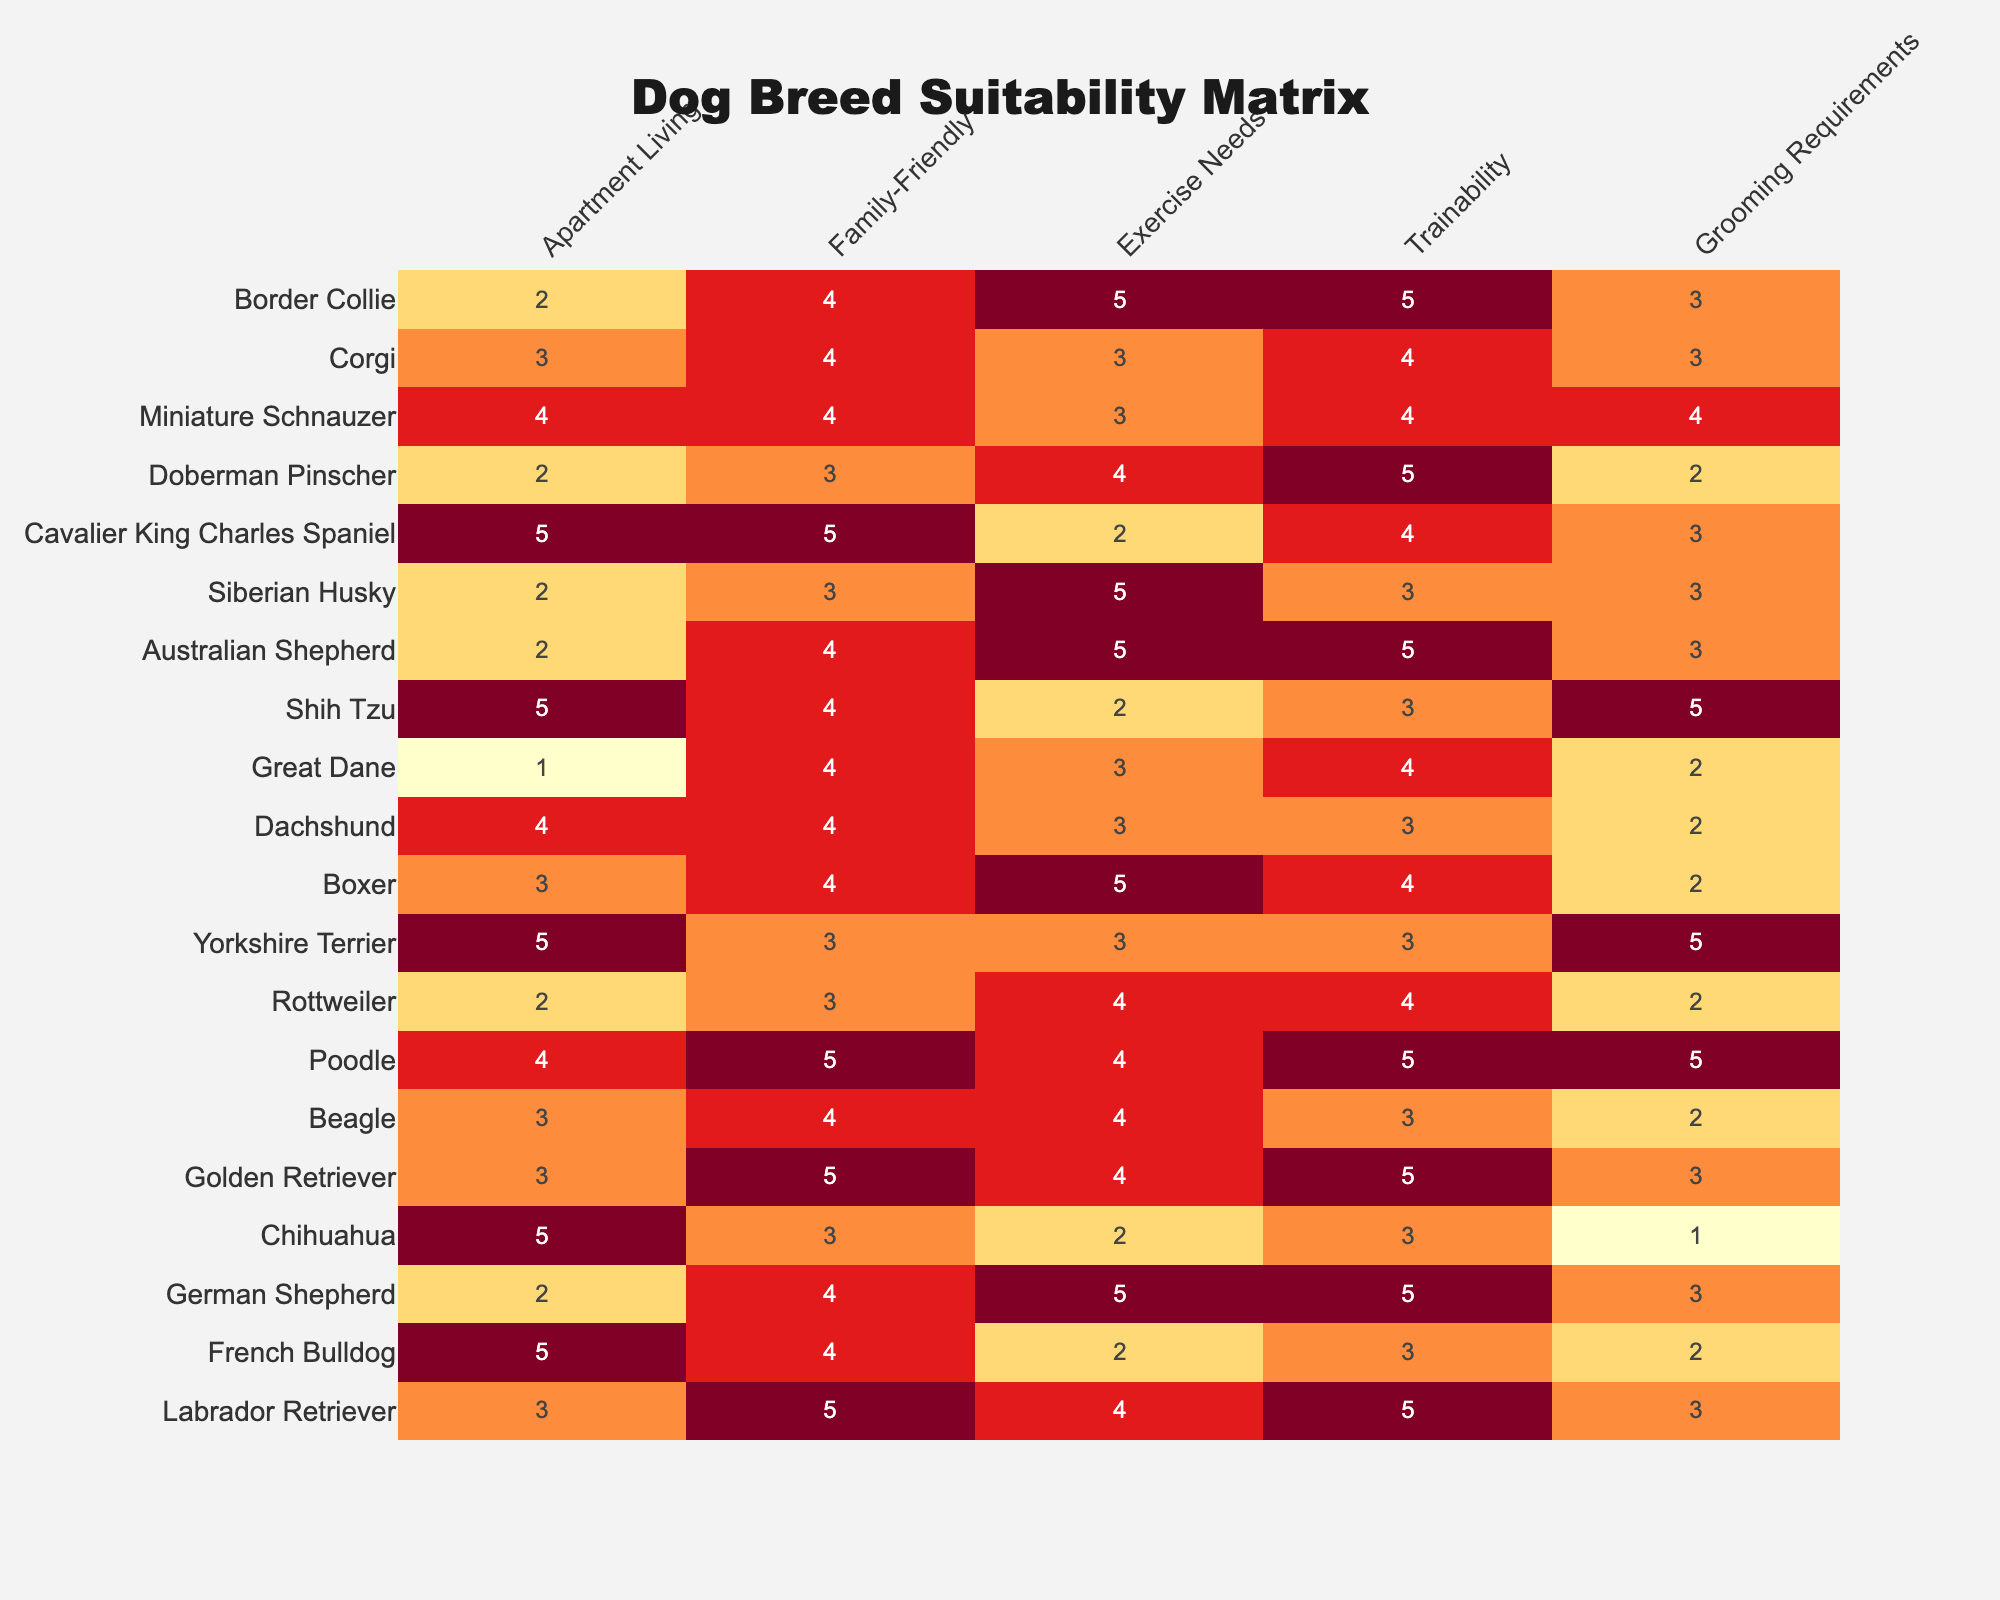What breed has the highest score for family-friendliness? The scores for family-friendliness are: Labrador Retriever (5), Golden Retriever (5), Poodle (5), and Cavalier King Charles Spaniel (5). Since multiple breeds have the highest score of 5, they all share this title.
Answer: Labrador Retriever, Golden Retriever, Poodle, Cavalier King Charles Spaniel Which dog breed has the lowest score for apartment living? The scores for apartment living show that Great Dane has the lowest score of 1 compared to other breeds.
Answer: Great Dane Is the Australian Shepherd suitable for families? The score for family-friendly is 4 which indicates that Australian Shepherds can be suitable for families, but there could be better options available.
Answer: Yes What is the average exercise need score for family-friendly breeds? The family-friendly breeds are Labrador Retriever (4), Golden Retriever (4), Beagle (4), Poodle (4), Cavalier King Charles Spaniel (2), and Boxer (5); summing their exercise need scores: (4 + 4 + 4 + 4 + 2 + 5) = 23. There are 6 data points, so the average is 23/6 = 3.83.
Answer: 3.83 Does a higher grooming requirement correlate with higher trainability? Looking closely, breeds such as Poodles have high grooming requirements (5) and high trainability (5), while breeds like Doberman Pinscher have lower grooming (2) and higher trainability (5). Hence, it does not specifically correlate.
Answer: No Which breed is the least trainable? The breed with the least trainability score is Chihuahua and Shih Tzu, both scoring 3, which is lower than others.
Answer: Chihuahua, Shih Tzu What breed has the best combination of family-friendliness and exercise needs? By considering family-friendliness (5 for Labrador Retriever, Golden Retriever, Poodle, and Cavalier King Charles Spaniel) and looking at their exercise needs: Labrador Retriever (4), Golden Retriever (4), and Poodle (4). All three have high scores in both categories, making them ideal choices.
Answer: Labrador Retriever, Golden Retriever, Poodle Are there any breeds suited for both apartment living and family-friendliness? Breeds scoring high for both are: Labrador Retriever (3 for apartment, 5 for family), and Cavalier King Charles Spaniel (5 for both), which shows that both can fit these criteria well.
Answer: Yes How many dog breeds have a grooming requirement score of 2 or less? The breeds with grooming requirements 2 or less are French Bulldog (2), Rottweiler (2), and Doberman Pinscher (2), making a total of 3 breeds fitting this criterion.
Answer: 3 Which dog breed has the highest total score in all categories? The total scores for the breeds are calculated and the highest total score belongs to Poodle with values: Apartment (4) + Family (5) + Exercise (4) + Trainability (5) + Grooming (5) = 23.
Answer: Poodle 